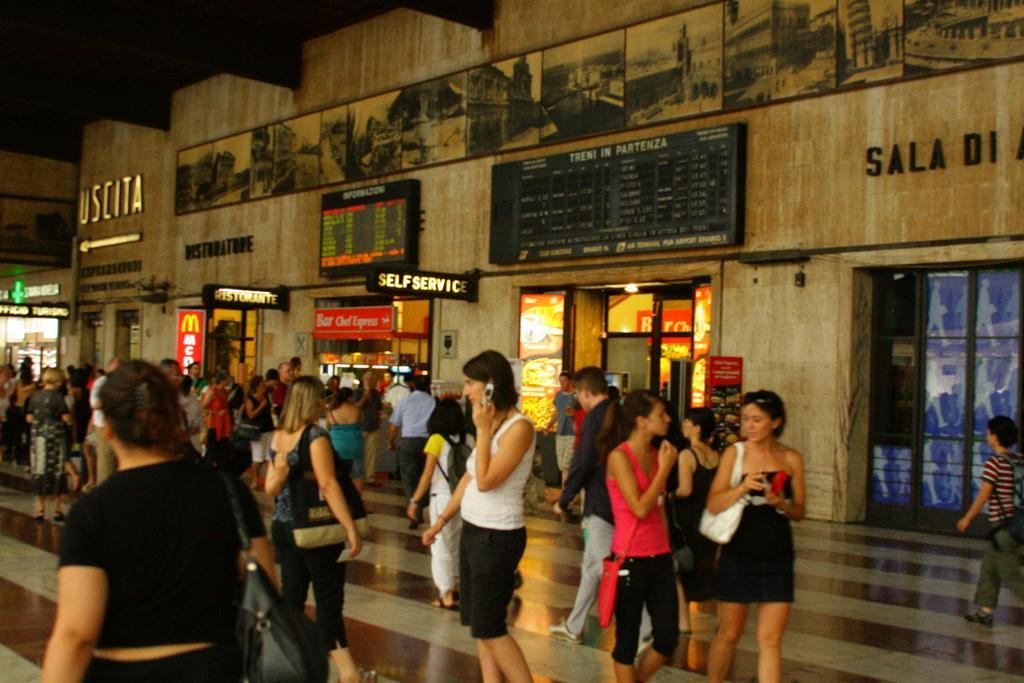Could you give a brief overview of what you see in this image? This picture seems to be clicked inside the hall. In the foreground we can see the group of persons and we can see the sling bags and in the center we can see a woman wearing white color t-shirt, standing and seems to be talking on a mobile phone. In the background we can see the text on the boards and we can see the doors, lights and some pictures and we can see many other objects. 